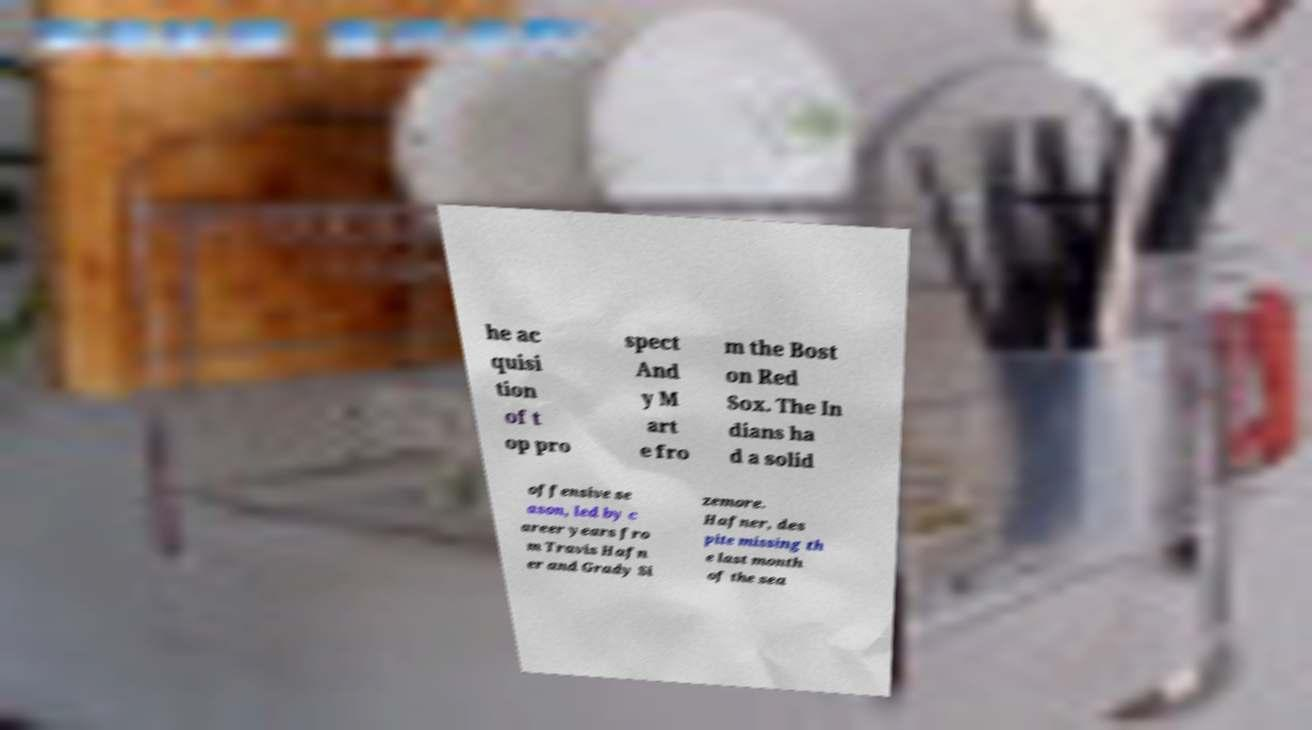Can you accurately transcribe the text from the provided image for me? he ac quisi tion of t op pro spect And y M art e fro m the Bost on Red Sox. The In dians ha d a solid offensive se ason, led by c areer years fro m Travis Hafn er and Grady Si zemore. Hafner, des pite missing th e last month of the sea 